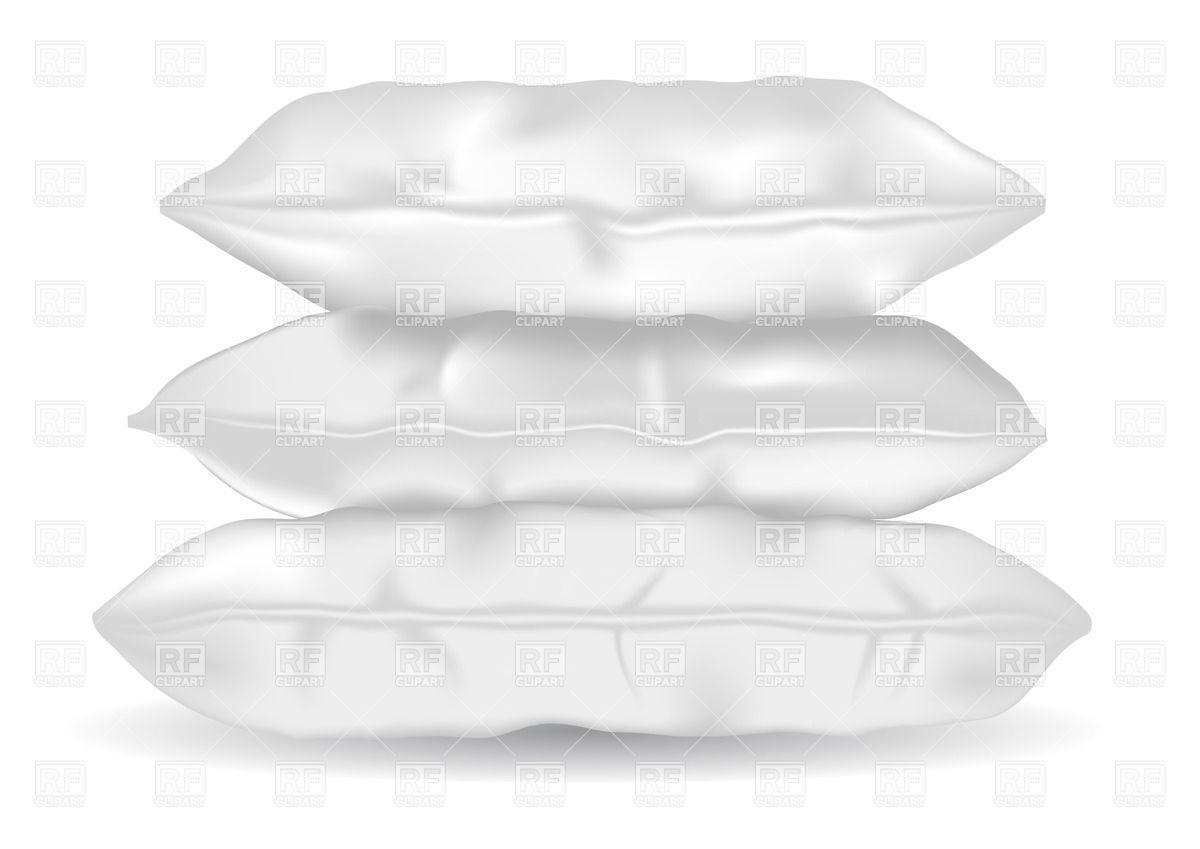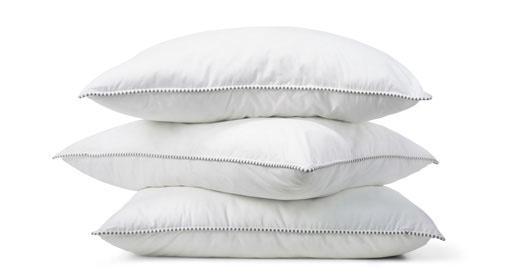The first image is the image on the left, the second image is the image on the right. For the images displayed, is the sentence "Left and right images each contain exactly three white pillows arranged in a vertical stack." factually correct? Answer yes or no. Yes. The first image is the image on the left, the second image is the image on the right. Examine the images to the left and right. Is the description "There are two stacks of three pillows." accurate? Answer yes or no. Yes. 